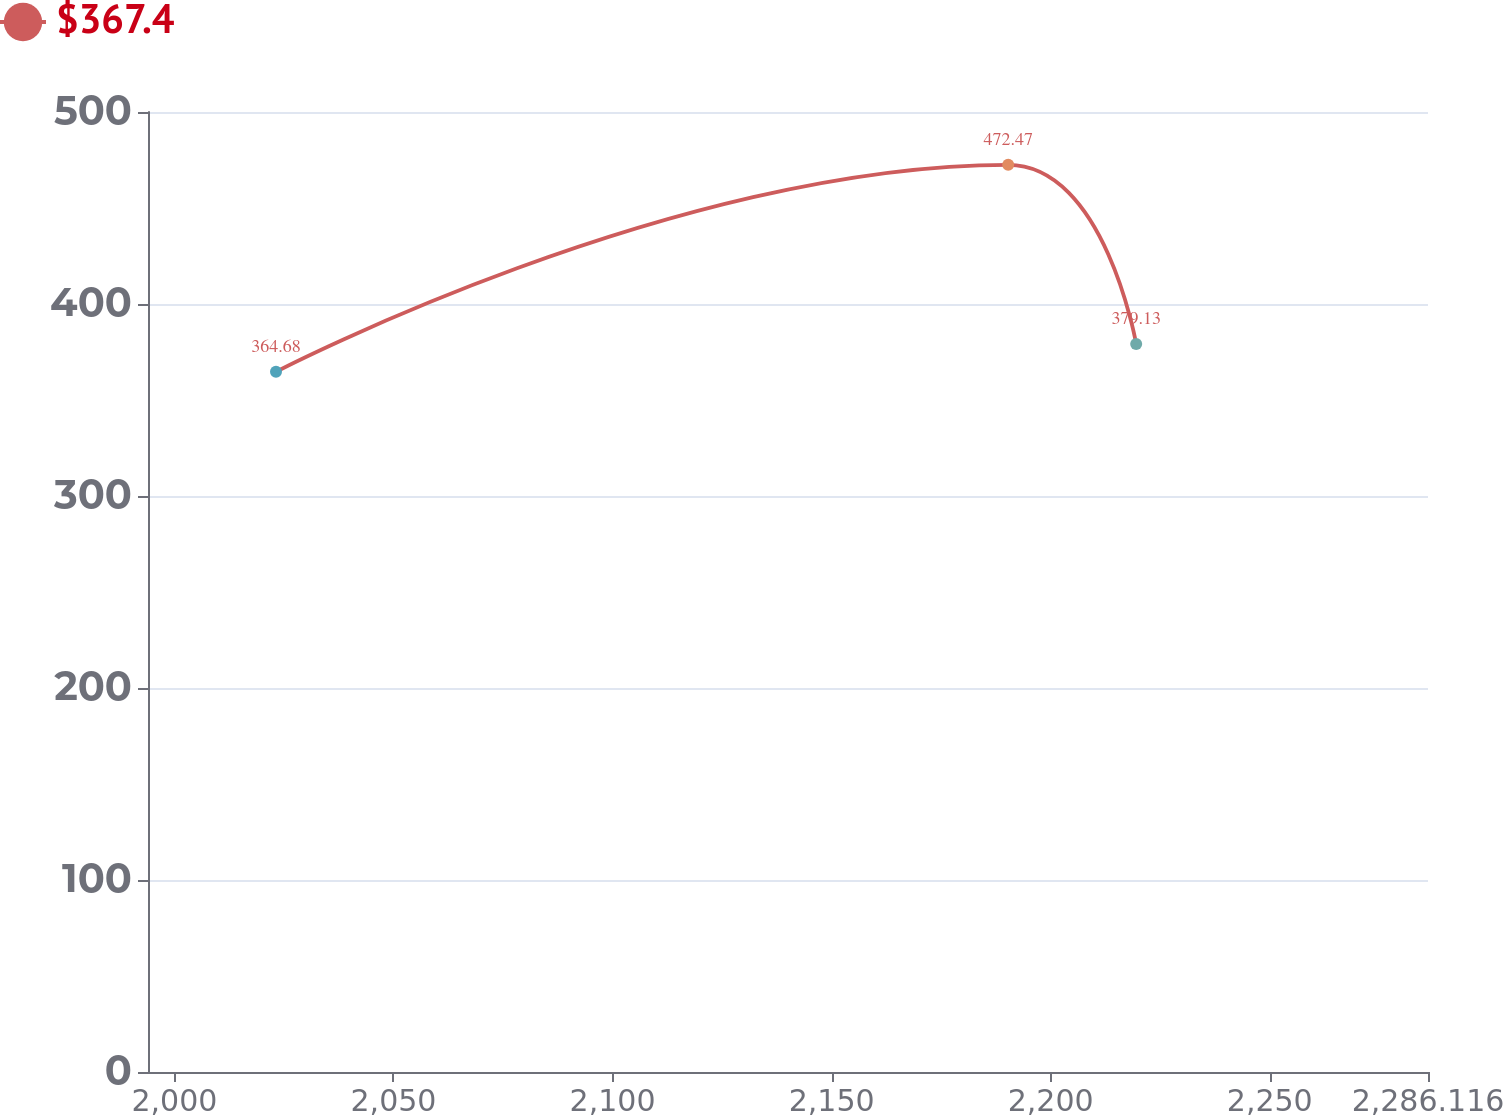<chart> <loc_0><loc_0><loc_500><loc_500><line_chart><ecel><fcel>$367.4<nl><fcel>2023.19<fcel>364.68<nl><fcel>2190.3<fcel>472.47<nl><fcel>2219.51<fcel>379.13<nl><fcel>2315.33<fcel>509.15<nl></chart> 